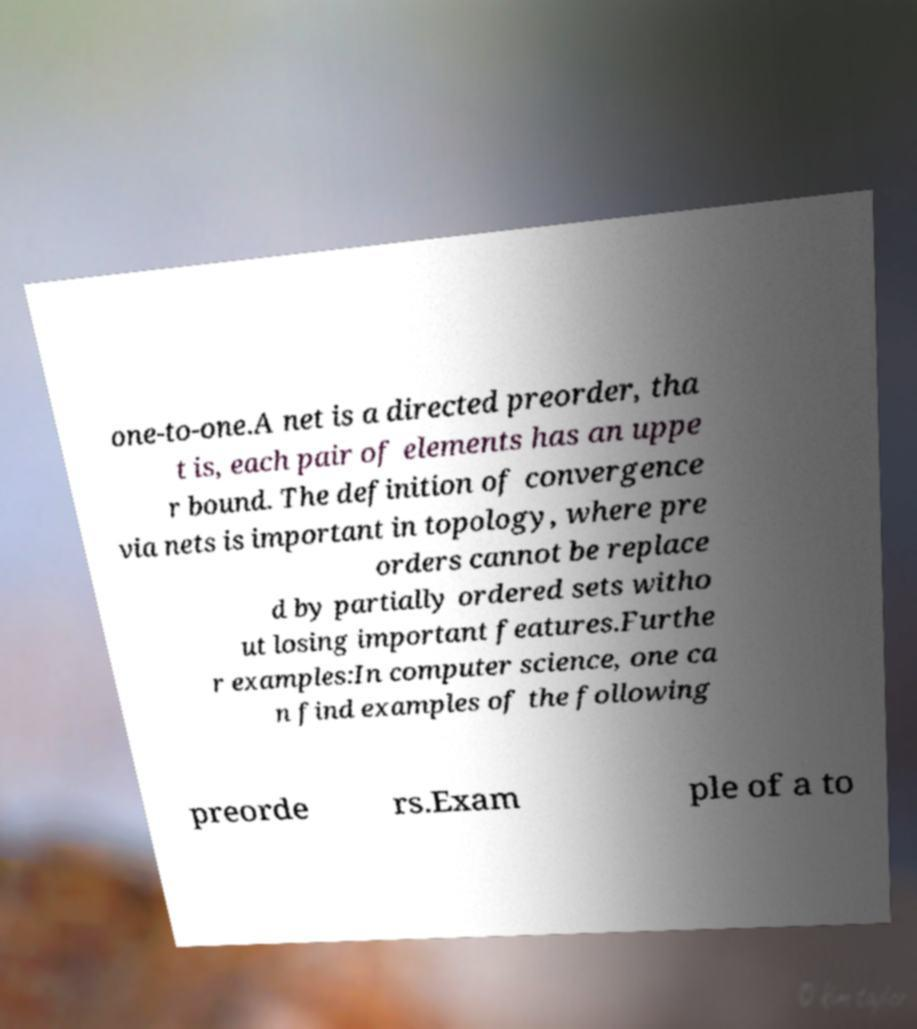There's text embedded in this image that I need extracted. Can you transcribe it verbatim? one-to-one.A net is a directed preorder, tha t is, each pair of elements has an uppe r bound. The definition of convergence via nets is important in topology, where pre orders cannot be replace d by partially ordered sets witho ut losing important features.Furthe r examples:In computer science, one ca n find examples of the following preorde rs.Exam ple of a to 